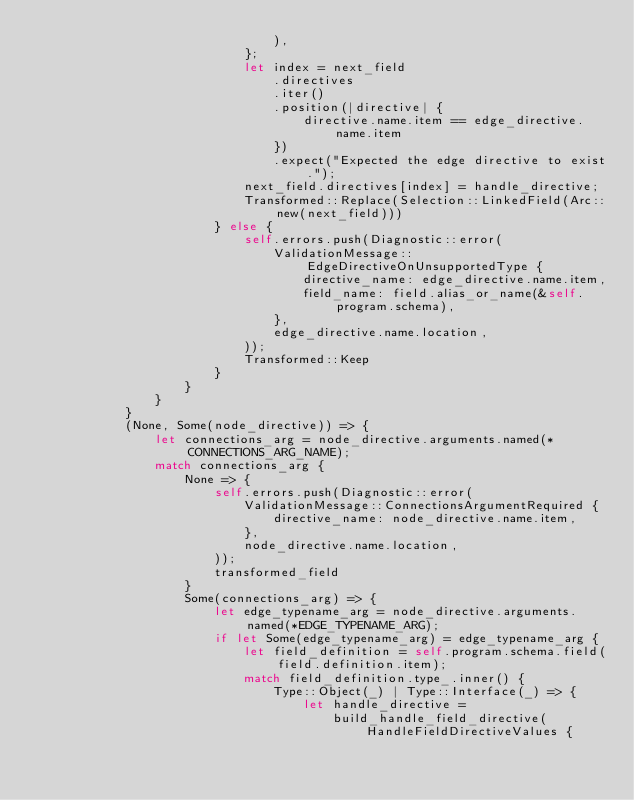<code> <loc_0><loc_0><loc_500><loc_500><_Rust_>                                ),
                            };
                            let index = next_field
                                .directives
                                .iter()
                                .position(|directive| {
                                    directive.name.item == edge_directive.name.item
                                })
                                .expect("Expected the edge directive to exist.");
                            next_field.directives[index] = handle_directive;
                            Transformed::Replace(Selection::LinkedField(Arc::new(next_field)))
                        } else {
                            self.errors.push(Diagnostic::error(
                                ValidationMessage::EdgeDirectiveOnUnsupportedType {
                                    directive_name: edge_directive.name.item,
                                    field_name: field.alias_or_name(&self.program.schema),
                                },
                                edge_directive.name.location,
                            ));
                            Transformed::Keep
                        }
                    }
                }
            }
            (None, Some(node_directive)) => {
                let connections_arg = node_directive.arguments.named(*CONNECTIONS_ARG_NAME);
                match connections_arg {
                    None => {
                        self.errors.push(Diagnostic::error(
                            ValidationMessage::ConnectionsArgumentRequired {
                                directive_name: node_directive.name.item,
                            },
                            node_directive.name.location,
                        ));
                        transformed_field
                    }
                    Some(connections_arg) => {
                        let edge_typename_arg = node_directive.arguments.named(*EDGE_TYPENAME_ARG);
                        if let Some(edge_typename_arg) = edge_typename_arg {
                            let field_definition = self.program.schema.field(field.definition.item);
                            match field_definition.type_.inner() {
                                Type::Object(_) | Type::Interface(_) => {
                                    let handle_directive =
                                        build_handle_field_directive(HandleFieldDirectiveValues {</code> 